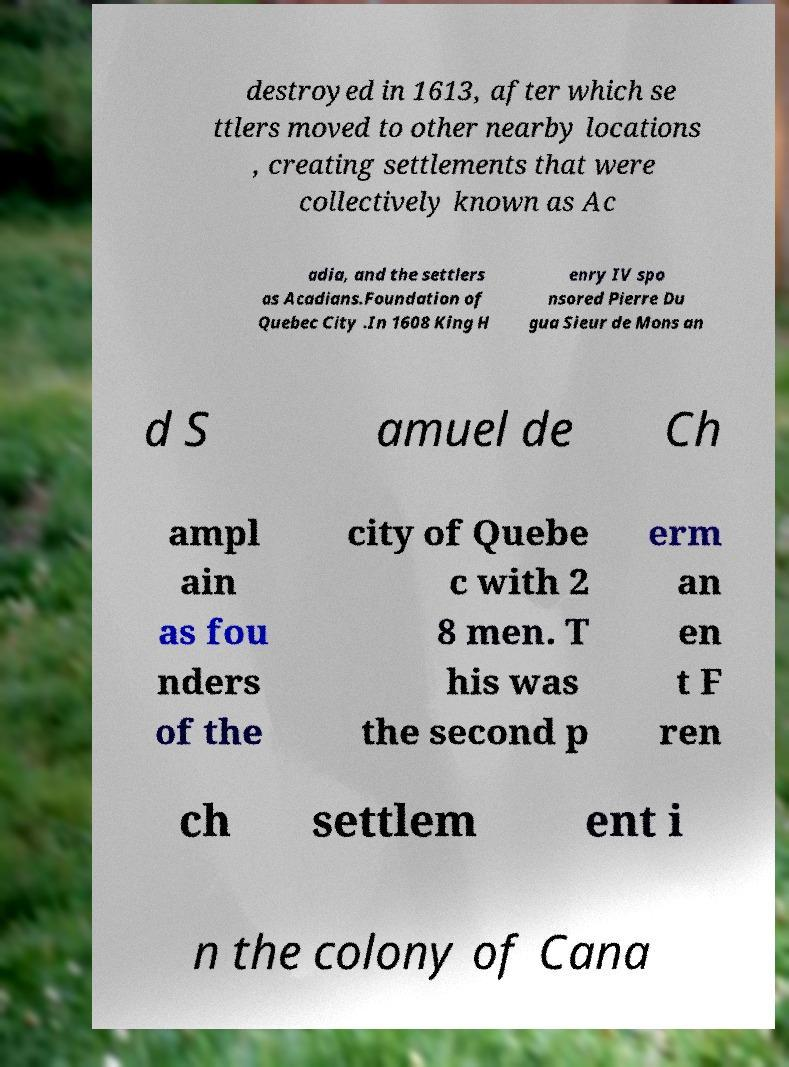I need the written content from this picture converted into text. Can you do that? destroyed in 1613, after which se ttlers moved to other nearby locations , creating settlements that were collectively known as Ac adia, and the settlers as Acadians.Foundation of Quebec City .In 1608 King H enry IV spo nsored Pierre Du gua Sieur de Mons an d S amuel de Ch ampl ain as fou nders of the city of Quebe c with 2 8 men. T his was the second p erm an en t F ren ch settlem ent i n the colony of Cana 